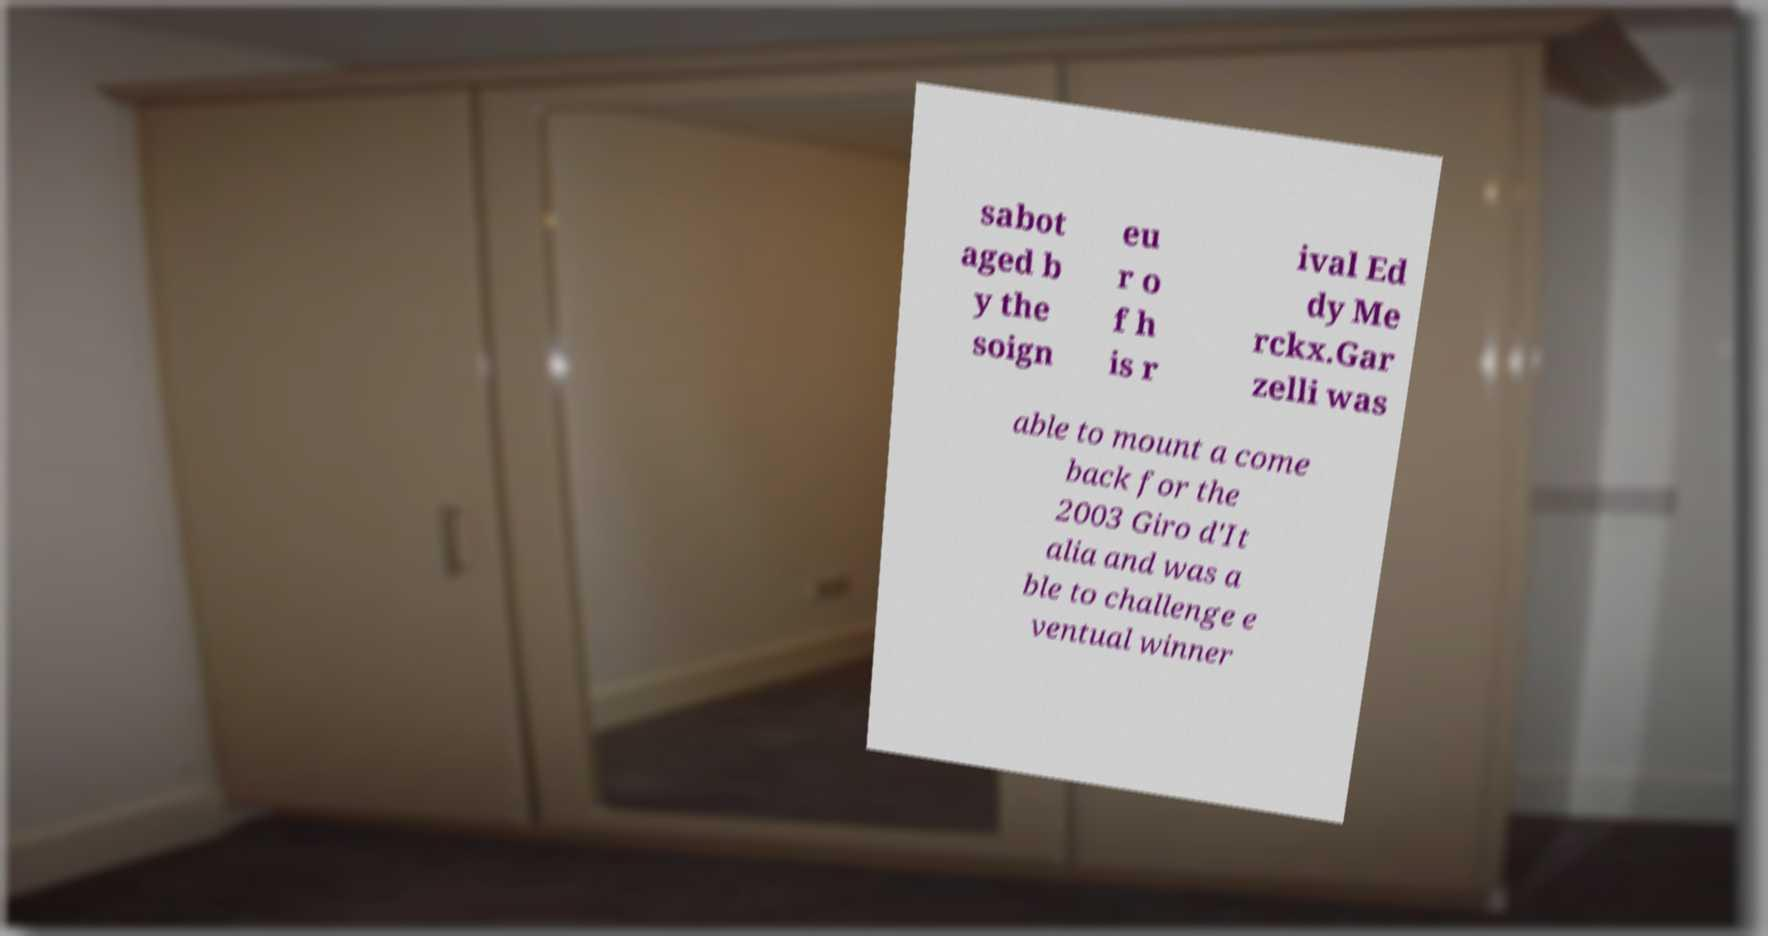There's text embedded in this image that I need extracted. Can you transcribe it verbatim? sabot aged b y the soign eu r o f h is r ival Ed dy Me rckx.Gar zelli was able to mount a come back for the 2003 Giro d'It alia and was a ble to challenge e ventual winner 